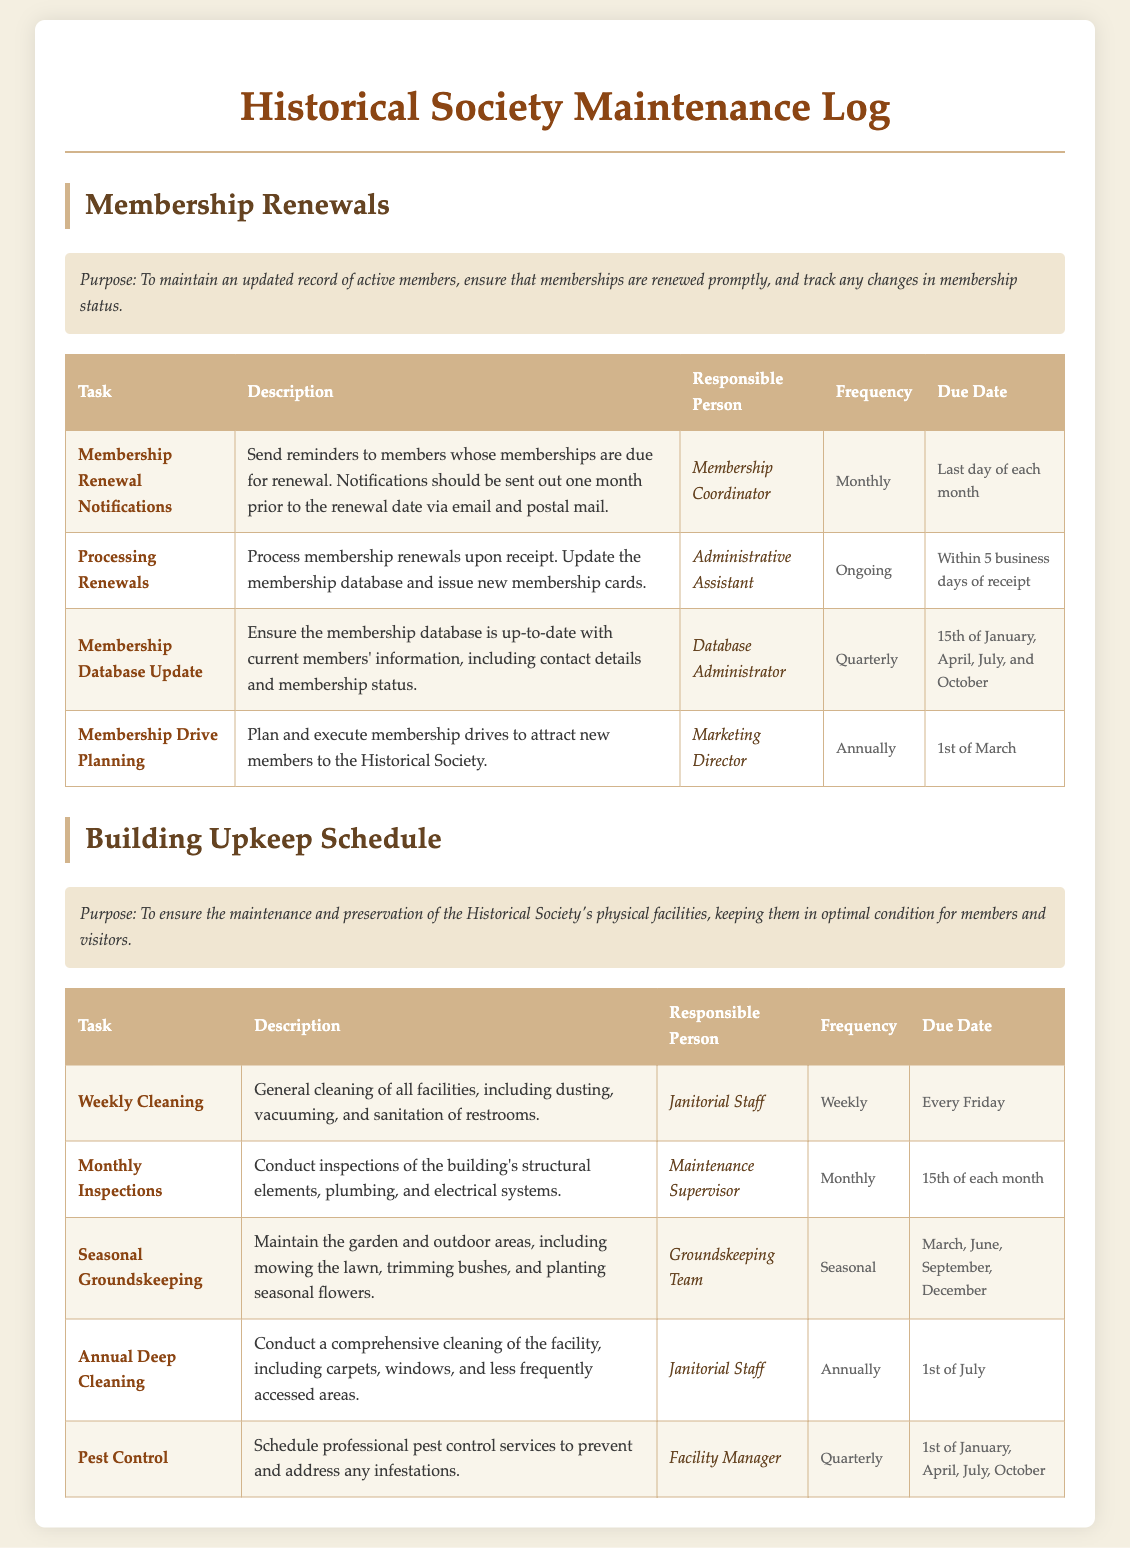What is the purpose of the membership renewals section? The purpose is to maintain an updated record of active members, ensure that memberships are renewed promptly, and track any changes in membership status.
Answer: To maintain an updated record of active members, ensure that memberships are renewed promptly, and track any changes in membership status Who is responsible for processing renewals? The person responsible for processing renewals is listed in the table under the "Responsible Person" column for that task.
Answer: Administrative Assistant How often are membership database updates conducted? The frequency of the membership database update is specified in the document.
Answer: Quarterly What date is the annual deep cleaning scheduled for? The due date for the annual deep cleaning is stated in the document, under the relevant task.
Answer: 1st of July How many tasks are listed under the Building Upkeep Schedule? The number of tasks can be counted from the table provided in the section.
Answer: Five What is the frequency of pest control services? The frequency of pest control services is mentioned in the maintenance log under the relevant task details.
Answer: Quarterly Who is in charge of membership drive planning? The responsible person for membership drive planning is indicated in the document.
Answer: Marketing Director What is the due date for weekly cleaning? The due date for the weekly cleaning task is listed in the relevant section of the document.
Answer: Every Friday When are the seasonal groundskeeping tasks due? The months for seasonal groundskeeping are provided in the document within the task details.
Answer: March, June, September, December 